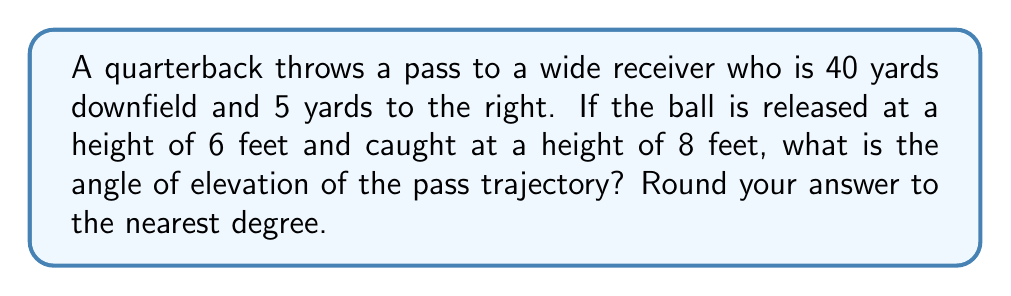Could you help me with this problem? Let's approach this step-by-step:

1) First, we need to find the horizontal distance of the pass. We can use the Pythagorean theorem:
   $$d = \sqrt{40^2 + 5^2} = \sqrt{1600 + 25} = \sqrt{1625} \approx 40.31 \text{ yards}$$

2) Now, we need to find the vertical rise of the ball:
   $$\text{Rise} = 8 \text{ feet} - 6 \text{ feet} = 2 \text{ feet}$$

3) We need to convert this to yards:
   $$2 \text{ feet} = \frac{2}{3} \text{ yards}$$

4) Now we have a right triangle where:
   - The base is 40.31 yards (horizontal distance)
   - The height is 2/3 yards (vertical rise)

5) We can find the angle of elevation using the tangent function:
   $$\tan(\theta) = \frac{\text{opposite}}{\text{adjacent}} = \frac{2/3}{40.31}$$

6) To solve for $\theta$, we use the inverse tangent (arctan):
   $$\theta = \arctan(\frac{2/3}{40.31})$$

7) Calculate and round to the nearest degree:
   $$\theta \approx 0.94^\circ \approx 1^\circ$$

[asy]
import geometry;

size(200);
real d = 40.31;
real h = 2/3;
real angle = atan(h/d);

draw((0,0)--(d,0)--(d,h)--(0,0));
draw((0,0)--(d,0), arrow=Arrow(TeXHead));
draw((d,0)--(d,h), arrow=Arrow(TeXHead));

label("40.31 yards", (d/2,0), S);
label("2/3 yards", (d,h/2), E);
label("$\theta$", (0,0), NW);

draw(arc((0,0),0.5,0,degrees(angle)), arrow=Arrow(TeXHead));
[/asy]
Answer: $1^\circ$ 